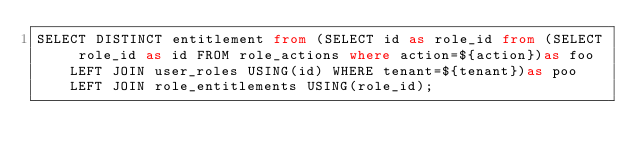<code> <loc_0><loc_0><loc_500><loc_500><_SQL_>SELECT DISTINCT entitlement from (SELECT id as role_id from (SELECT role_id as id FROM role_actions where action=${action})as foo LEFT JOIN user_roles USING(id) WHERE tenant=${tenant})as poo LEFT JOIN role_entitlements USING(role_id);
</code> 